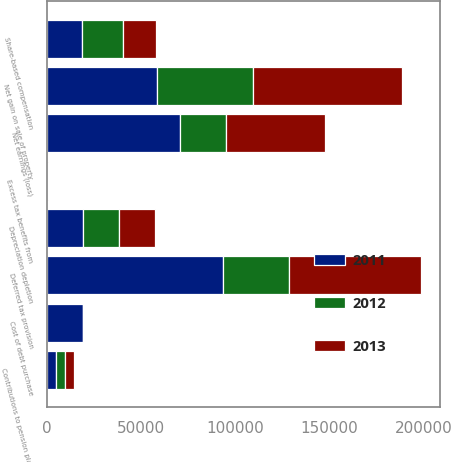<chart> <loc_0><loc_0><loc_500><loc_500><stacked_bar_chart><ecel><fcel>Net earnings (loss)<fcel>Depreciation depletion<fcel>Net gain on sale of property<fcel>Contributions to pension plans<fcel>Share-based compensation<fcel>Excess tax benefits from<fcel>Deferred tax provision<fcel>Cost of debt purchase<nl><fcel>2012<fcel>24382<fcel>19153<fcel>50978<fcel>4855<fcel>22093<fcel>161<fcel>35063<fcel>0<nl><fcel>2013<fcel>52593<fcel>19153<fcel>78654<fcel>4509<fcel>17474<fcel>267<fcel>69830<fcel>0<nl><fcel>2011<fcel>70778<fcel>19153<fcel>58808<fcel>4892<fcel>18454<fcel>121<fcel>93739<fcel>19153<nl></chart> 